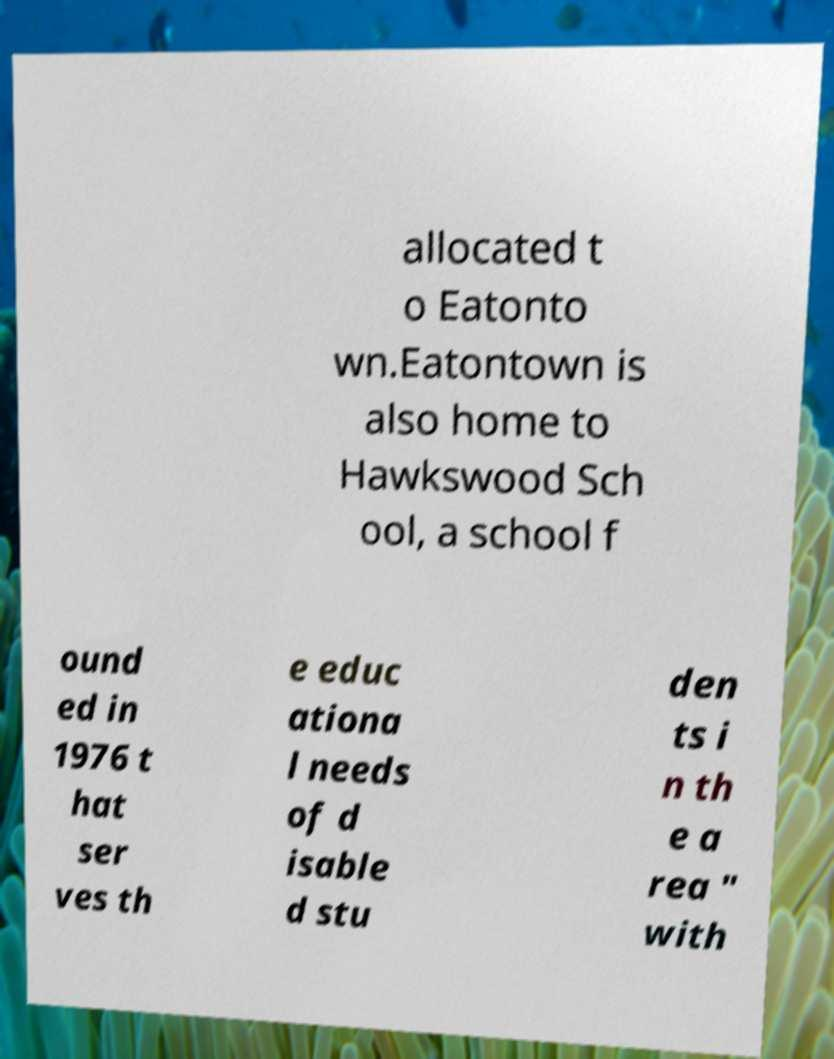Please identify and transcribe the text found in this image. allocated t o Eatonto wn.Eatontown is also home to Hawkswood Sch ool, a school f ound ed in 1976 t hat ser ves th e educ ationa l needs of d isable d stu den ts i n th e a rea " with 